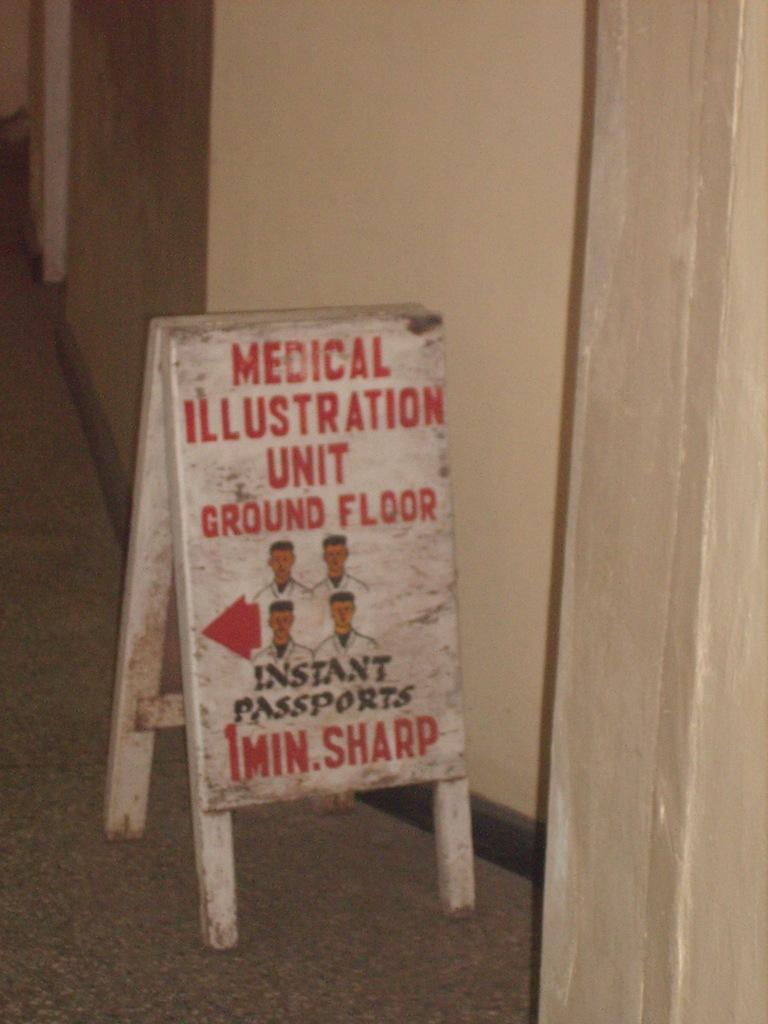What is the main object in the image with text on it? There is a board with text in the image. Where is the board located in the image? The board is in the front of the image. What can be seen on the right side of the image? There is a curtain on the right side of the image. What is visible in the background of the image? There is a wall in the background of the image. What type of feast is being prepared behind the curtain in the image? There is no indication of a feast or any preparation in the image; it only features a board with text, a curtain, and a wall in the background. 